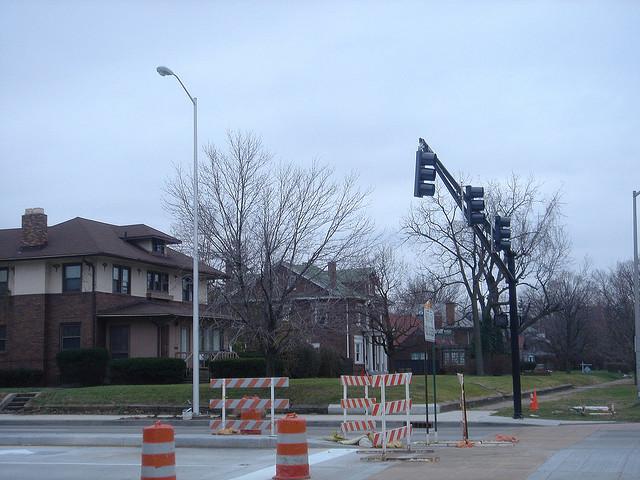How is traffic at this intersection?
Keep it brief. Clear. Can anyone drive through this road?
Keep it brief. No. How many flags?
Quick response, please. 0. What is between the tree and the fire hydrant?
Concise answer only. Grass. Is it a sunny day?
Quick response, please. No. How many orange barrels do you see?
Answer briefly. 2. What is cast?
Quick response, please. Sky. Could this tree be "budding"?
Be succinct. No. How many barricades are shown?
Be succinct. 3. 